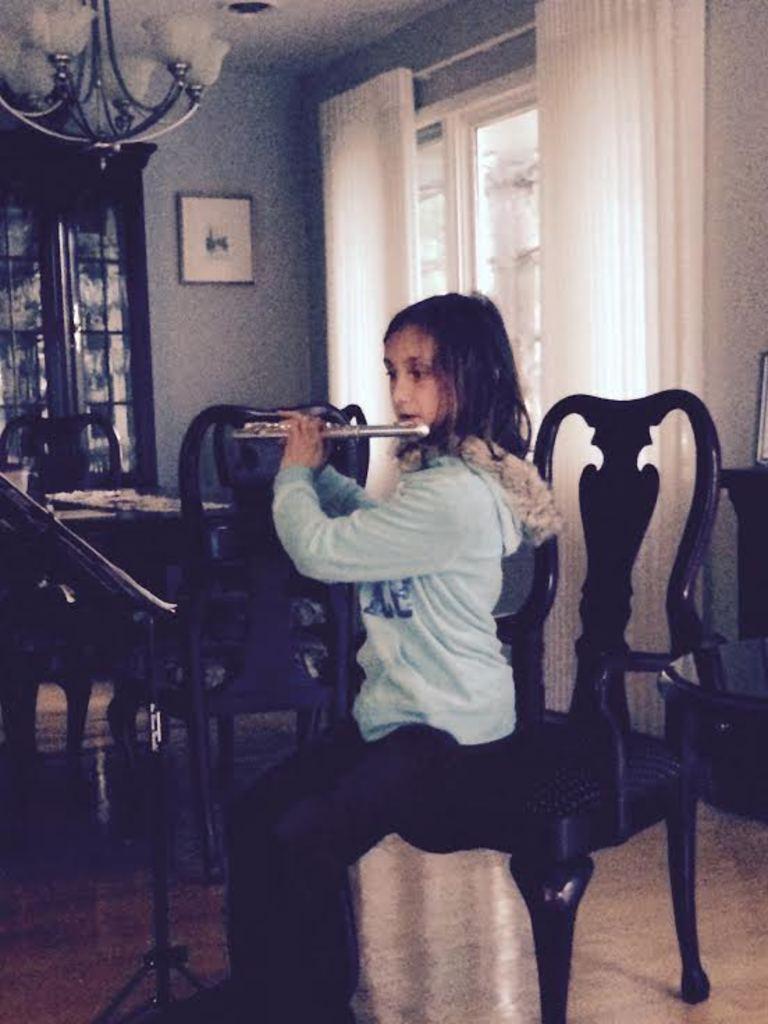How would you summarize this image in a sentence or two? In the image we can see one girl sitting on the chair and holding musical instrument. In the background there is a wall,curtain,window,photo frame,table and chairs. 